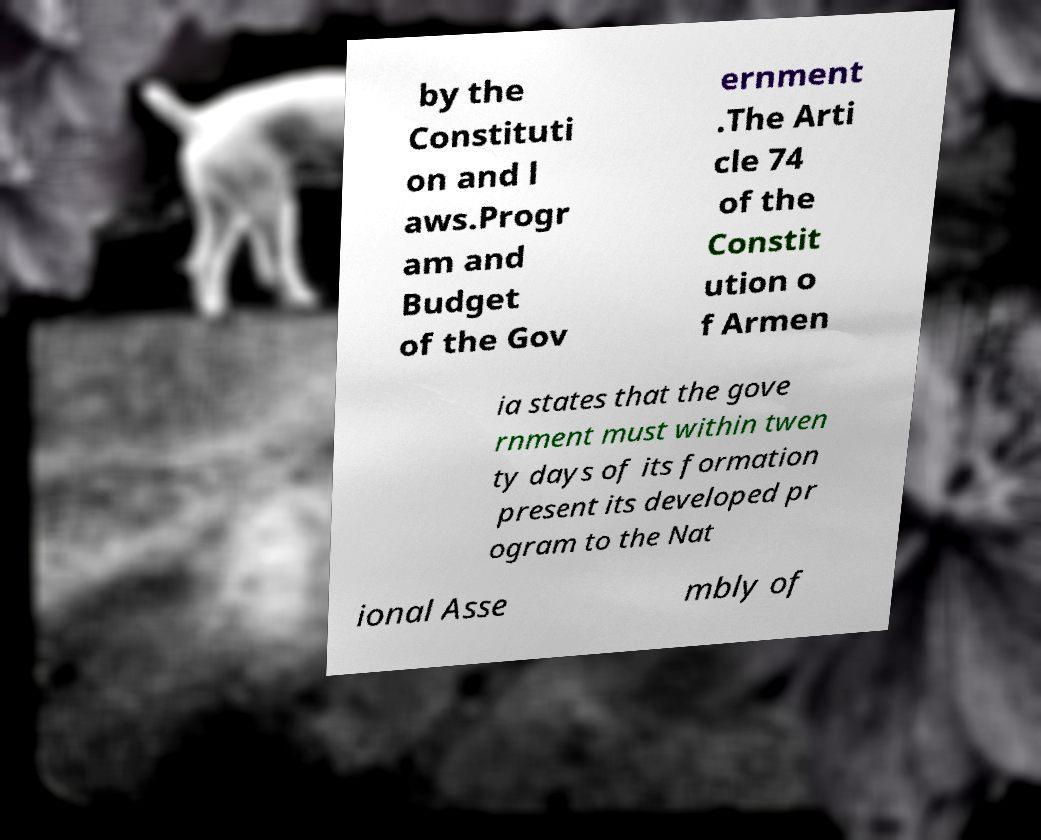Could you extract and type out the text from this image? by the Constituti on and l aws.Progr am and Budget of the Gov ernment .The Arti cle 74 of the Constit ution o f Armen ia states that the gove rnment must within twen ty days of its formation present its developed pr ogram to the Nat ional Asse mbly of 